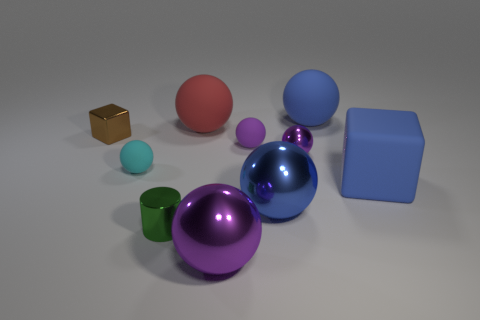There is a matte sphere that is the same color as the small metallic sphere; what size is it?
Your answer should be compact. Small. The large purple object is what shape?
Your response must be concise. Sphere. What shape is the big red rubber object to the right of the tiny metal object that is in front of the blue matte block?
Provide a succinct answer. Sphere. What number of other objects are the same shape as the big red matte object?
Your answer should be very brief. 6. How big is the rubber object that is right of the large rubber ball to the right of the small purple rubber sphere?
Make the answer very short. Large. Is there a tiny yellow metallic object?
Offer a terse response. No. There is a blue rubber object behind the brown metal cube; what number of green things are on the right side of it?
Give a very brief answer. 0. There is a tiny shiny object that is in front of the tiny cyan thing; what shape is it?
Offer a very short reply. Cylinder. The blue ball that is right of the big blue ball in front of the blue matte object that is in front of the tiny cube is made of what material?
Provide a short and direct response. Rubber. What number of other objects are the same size as the cylinder?
Your answer should be compact. 4. 